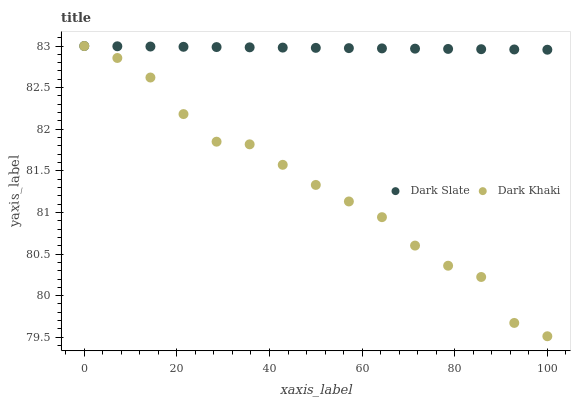Does Dark Khaki have the minimum area under the curve?
Answer yes or no. Yes. Does Dark Slate have the maximum area under the curve?
Answer yes or no. Yes. Does Dark Slate have the minimum area under the curve?
Answer yes or no. No. Is Dark Slate the smoothest?
Answer yes or no. Yes. Is Dark Khaki the roughest?
Answer yes or no. Yes. Is Dark Slate the roughest?
Answer yes or no. No. Does Dark Khaki have the lowest value?
Answer yes or no. Yes. Does Dark Slate have the lowest value?
Answer yes or no. No. Does Dark Slate have the highest value?
Answer yes or no. Yes. Does Dark Slate intersect Dark Khaki?
Answer yes or no. Yes. Is Dark Slate less than Dark Khaki?
Answer yes or no. No. Is Dark Slate greater than Dark Khaki?
Answer yes or no. No. 